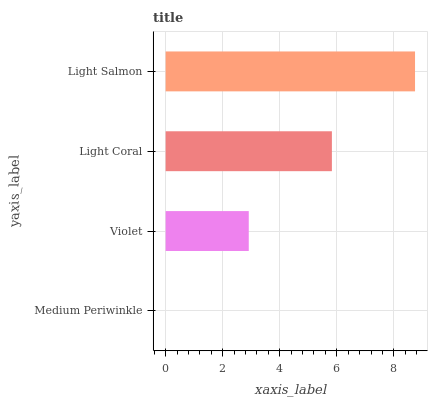Is Medium Periwinkle the minimum?
Answer yes or no. Yes. Is Light Salmon the maximum?
Answer yes or no. Yes. Is Violet the minimum?
Answer yes or no. No. Is Violet the maximum?
Answer yes or no. No. Is Violet greater than Medium Periwinkle?
Answer yes or no. Yes. Is Medium Periwinkle less than Violet?
Answer yes or no. Yes. Is Medium Periwinkle greater than Violet?
Answer yes or no. No. Is Violet less than Medium Periwinkle?
Answer yes or no. No. Is Light Coral the high median?
Answer yes or no. Yes. Is Violet the low median?
Answer yes or no. Yes. Is Light Salmon the high median?
Answer yes or no. No. Is Medium Periwinkle the low median?
Answer yes or no. No. 